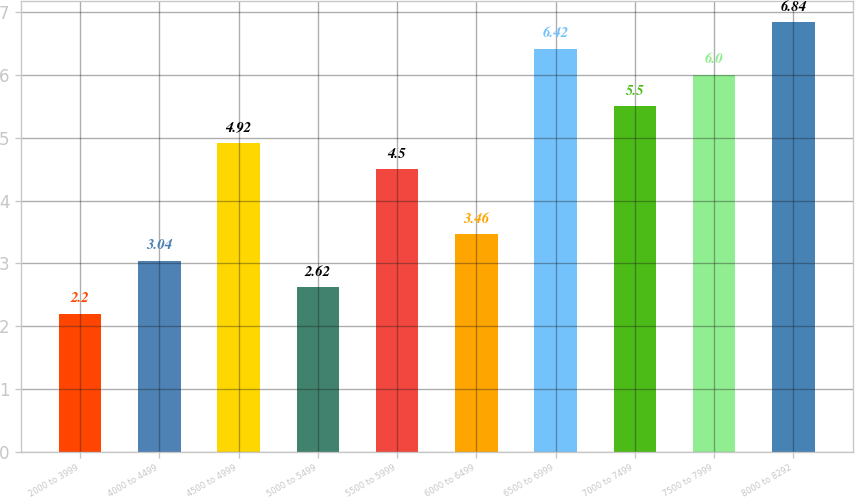Convert chart. <chart><loc_0><loc_0><loc_500><loc_500><bar_chart><fcel>2000 to 3999<fcel>4000 to 4499<fcel>4500 to 4999<fcel>5000 to 5499<fcel>5500 to 5999<fcel>6000 to 6499<fcel>6500 to 6999<fcel>7000 to 7499<fcel>7500 to 7999<fcel>8000 to 8292<nl><fcel>2.2<fcel>3.04<fcel>4.92<fcel>2.62<fcel>4.5<fcel>3.46<fcel>6.42<fcel>5.5<fcel>6<fcel>6.84<nl></chart> 